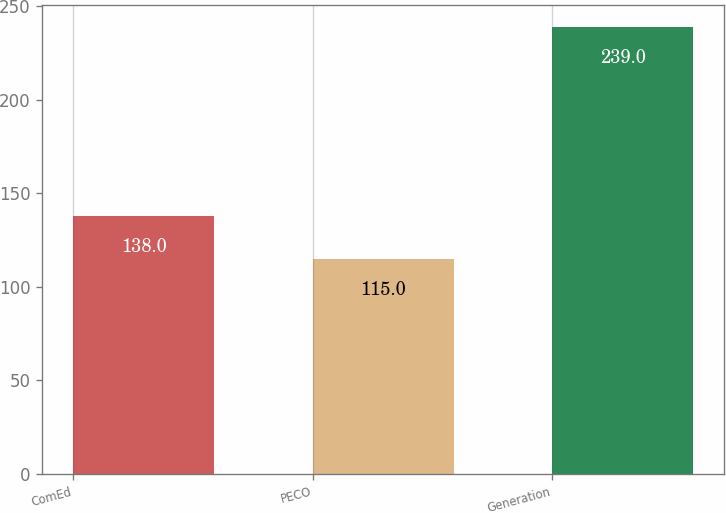Convert chart to OTSL. <chart><loc_0><loc_0><loc_500><loc_500><bar_chart><fcel>ComEd<fcel>PECO<fcel>Generation<nl><fcel>138<fcel>115<fcel>239<nl></chart> 